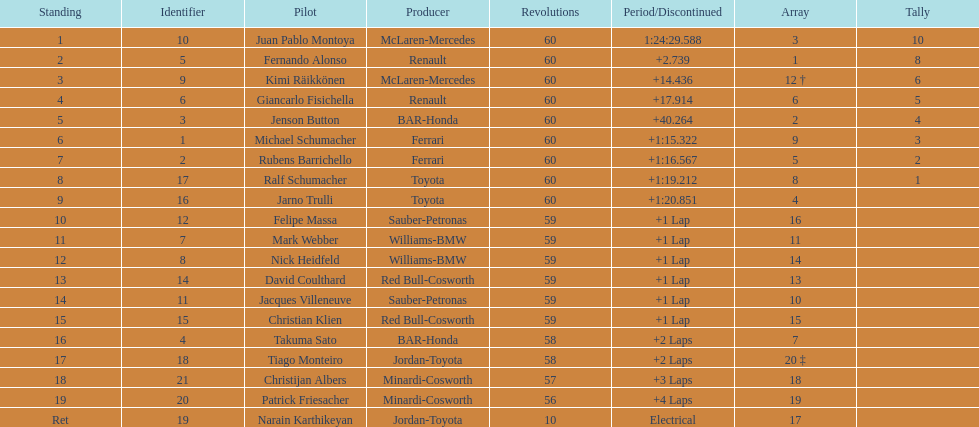Which driver came after giancarlo fisichella? Jenson Button. 